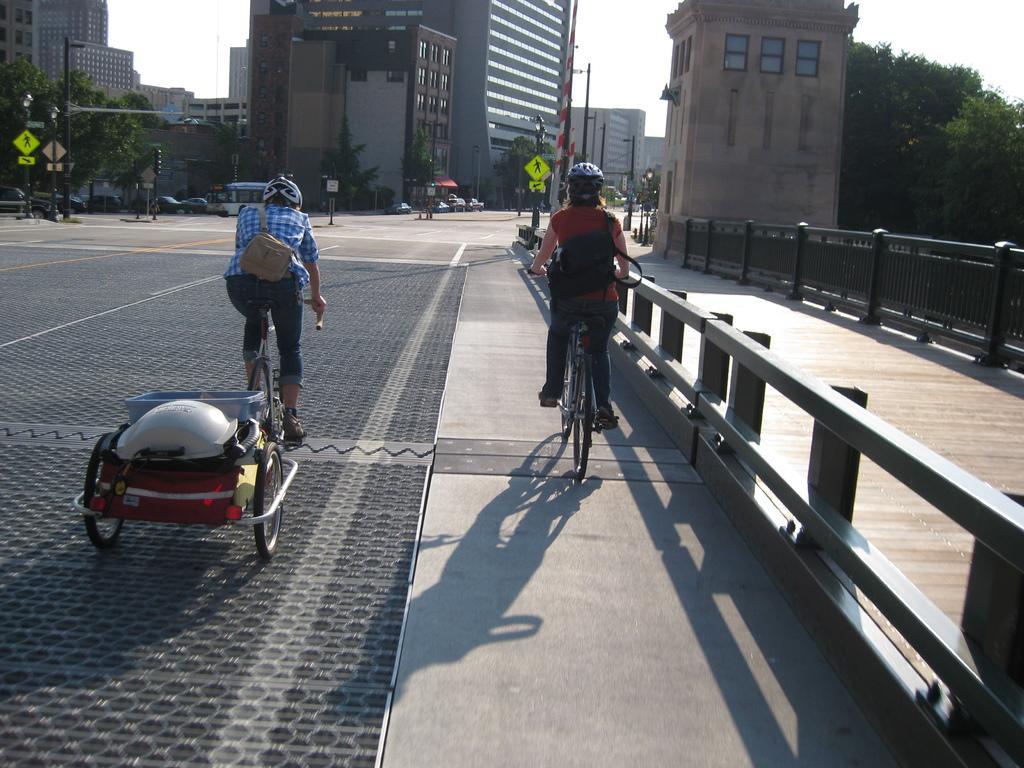In one or two sentences, can you explain what this image depicts? This is the picture of a place where we have two people riding the cycles and to the side there is a fencing and also we can see some buildings, trees, plants, poles which has some lights and sign boards. 